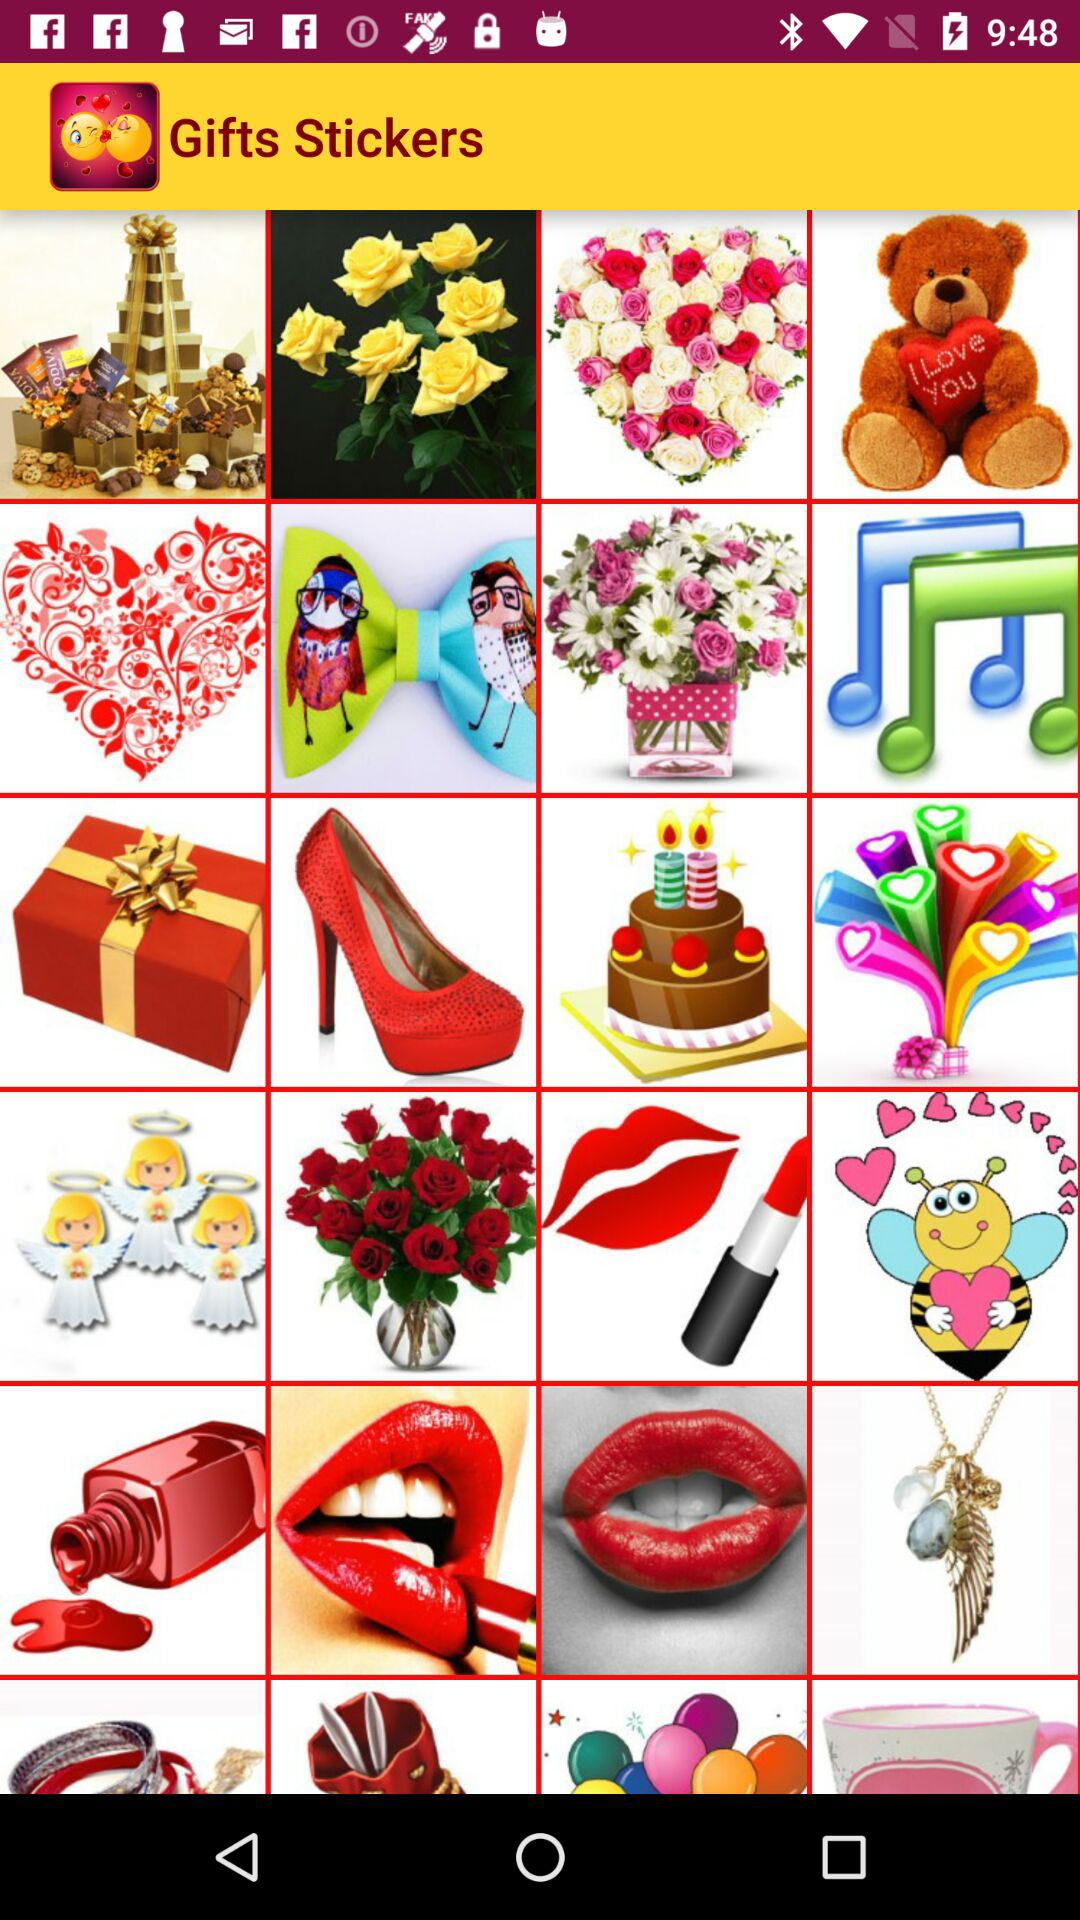What is the application name? The application name is "Gifts Stickers". 